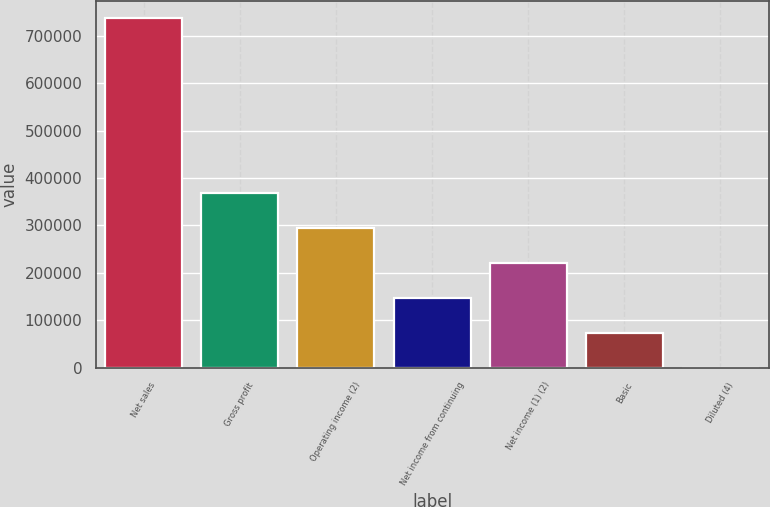Convert chart to OTSL. <chart><loc_0><loc_0><loc_500><loc_500><bar_chart><fcel>Net sales<fcel>Gross profit<fcel>Operating income (2)<fcel>Net income from continuing<fcel>Net income (1) (2)<fcel>Basic<fcel>Diluted (4)<nl><fcel>737997<fcel>368999<fcel>295199<fcel>147600<fcel>221399<fcel>73800.2<fcel>0.55<nl></chart> 